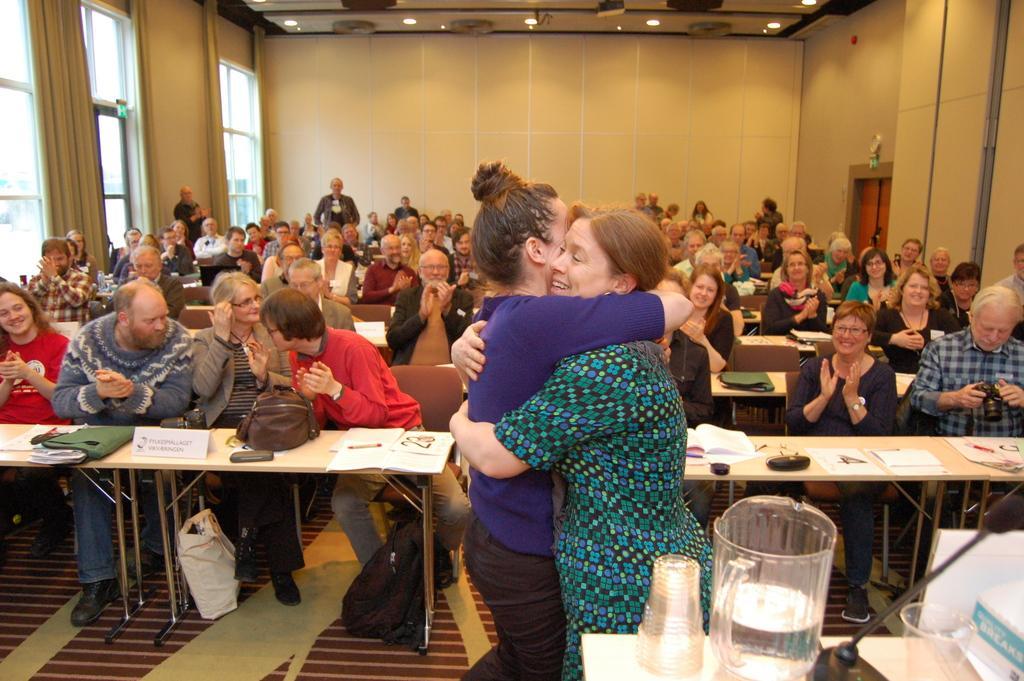Describe this image in one or two sentences. In the picture we can see a group of people sitting on the chairs near the tables, and two people are standing and hugging and standing near the table, on the table we can find a jug, glass, and a microphone stand. In the background we can find a wall glass windows and curtain. To the ceiling we can see a lights. 